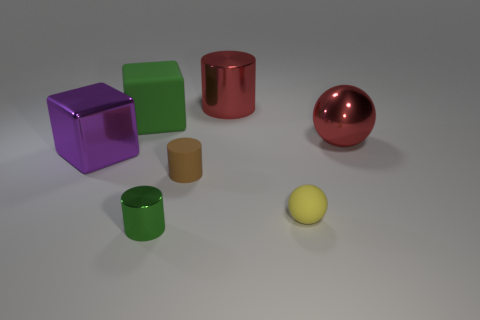Subtract all tiny cylinders. How many cylinders are left? 1 Add 2 tiny brown cylinders. How many objects exist? 9 Subtract 1 cubes. How many cubes are left? 1 Subtract all green cylinders. How many cylinders are left? 2 Add 7 small green rubber cubes. How many small green rubber cubes exist? 7 Subtract 1 yellow balls. How many objects are left? 6 Subtract all blocks. How many objects are left? 5 Subtract all gray cubes. Subtract all green balls. How many cubes are left? 2 Subtract all blue blocks. Subtract all large cylinders. How many objects are left? 6 Add 4 big purple cubes. How many big purple cubes are left? 5 